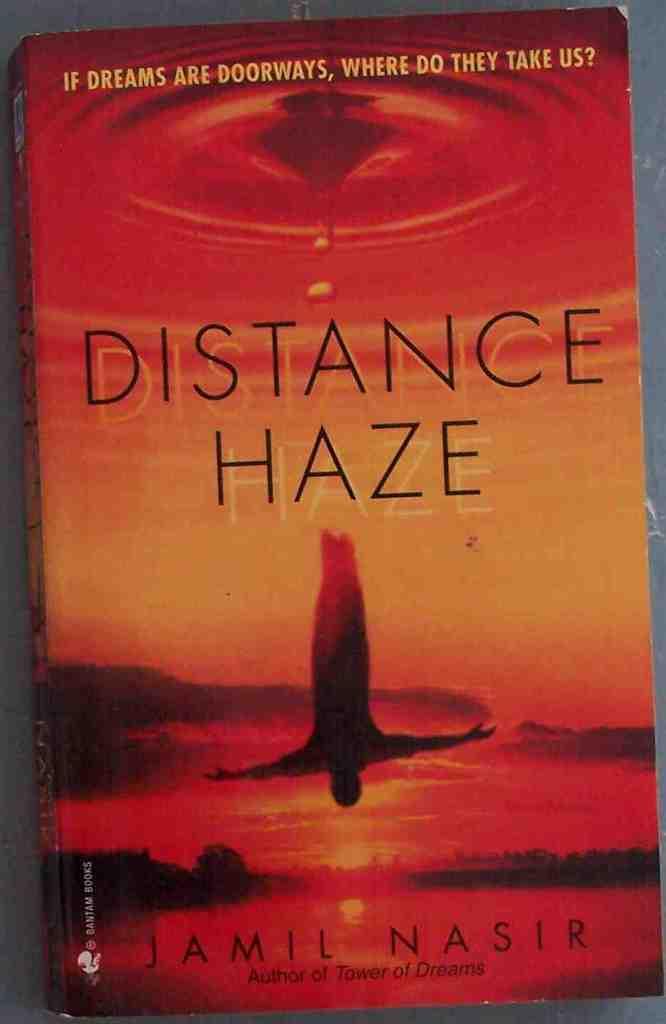What is the title of this book?
Ensure brevity in your answer.  Distance haze. 